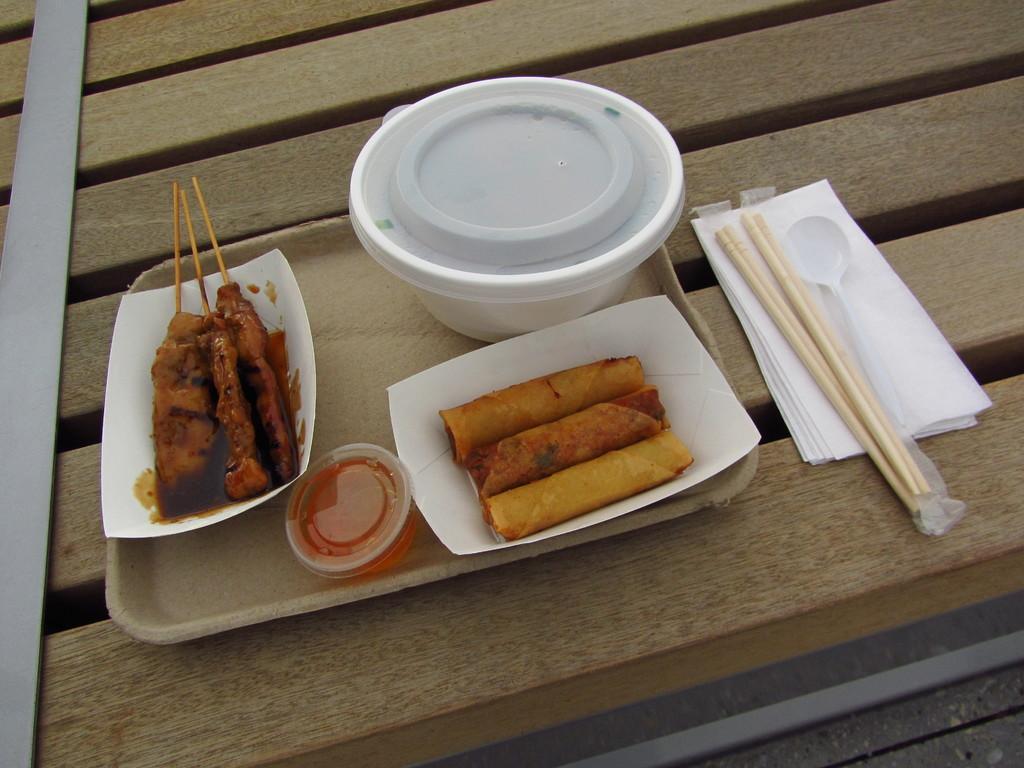How would you summarize this image in a sentence or two? In this image there is a table on which tray, tissue papers, spoon, bowl, plate and food items are kept. This image is taken inside a room. 